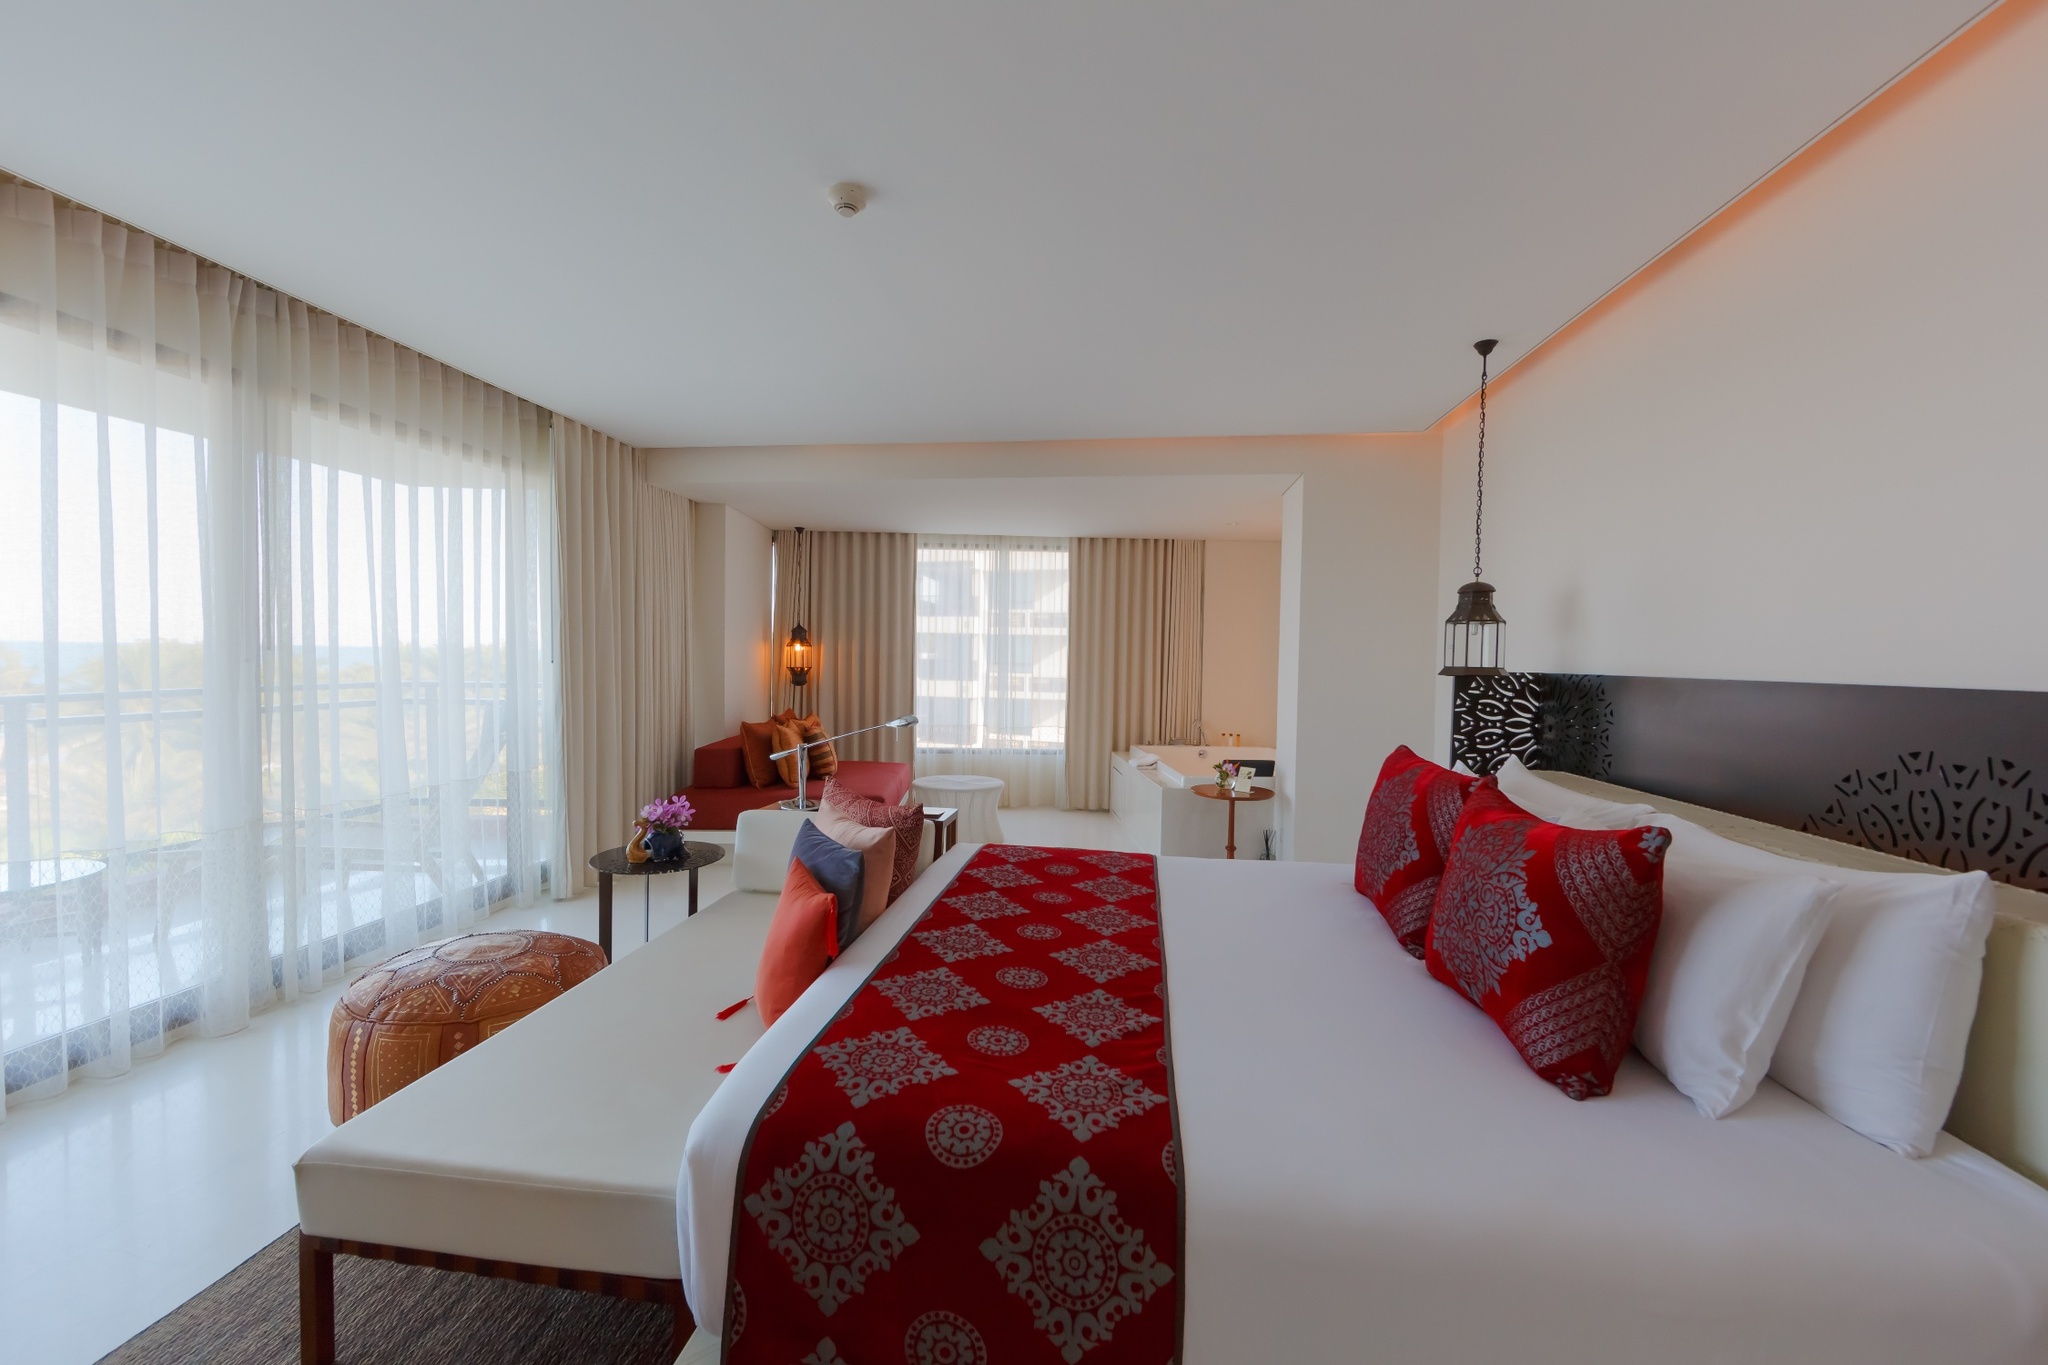What do you think the view from the balcony looks like? Based on the ample natural light flowing through the large windows, the view from the balcony likely offers a breathtaking panorama. One can imagine gazing out upon a serene landscape, possibly lush greenery or a distant horizon. The gentle breeze can be felt as you stand on the balcony, taking in the vast expanse below with unobstructed views unique to the hotel’s location. Describe the experience of staying in this hotel room for a weekend. Staying in this hotel room for a weekend would be rejuvenating. Waking up to the gentle sunlight streaming through the curtain-draped windows, you step out onto the balcony to enjoy a fresh morning breeze and stunning views. The room’s modern decor, with its blend of white and natural wood tones, creates a soothing ambiance. The cozy seating area becomes a perfect spot for relaxing with a book or enjoying a quiet cup of coffee. The spacious room layout allows you to work at the desk by the window, bathed in natural light, while still feeling connected to the space’s luxurious comfort. As the day winds down, the soft lighting and plush bed with its accented pillows invite you to a restful sleep, making your weekend stay both tranquil and invigorating. 